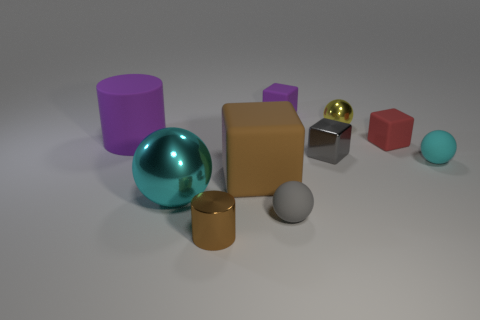Subtract all tiny gray blocks. How many blocks are left? 3 Subtract all gray blocks. How many blocks are left? 3 Subtract all purple cylinders. How many cyan balls are left? 2 Subtract 2 balls. How many balls are left? 2 Subtract 2 cyan spheres. How many objects are left? 8 Subtract all cubes. How many objects are left? 6 Subtract all green cylinders. Subtract all red blocks. How many cylinders are left? 2 Subtract all brown cylinders. Subtract all tiny brown cylinders. How many objects are left? 8 Add 8 large purple matte cylinders. How many large purple matte cylinders are left? 9 Add 6 brown metal objects. How many brown metal objects exist? 7 